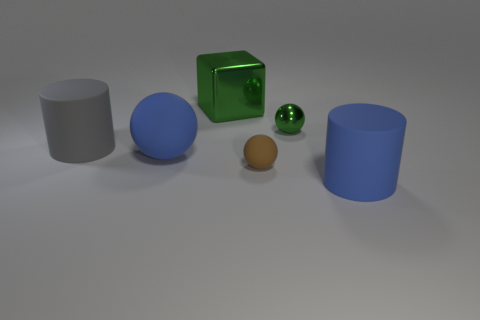Subtract all gray spheres. Subtract all brown cubes. How many spheres are left? 3 Add 3 cyan cubes. How many objects exist? 9 Subtract all cylinders. How many objects are left? 4 Add 6 large blue cylinders. How many large blue cylinders exist? 7 Subtract 1 green cubes. How many objects are left? 5 Subtract all big blue rubber things. Subtract all matte spheres. How many objects are left? 2 Add 5 gray matte cylinders. How many gray matte cylinders are left? 6 